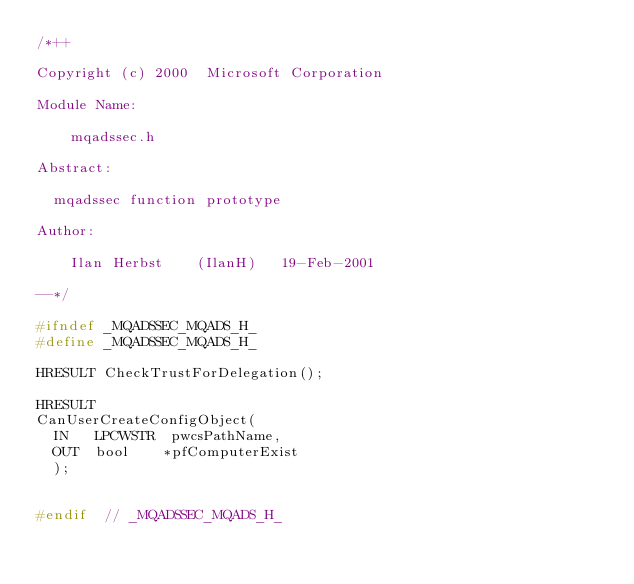<code> <loc_0><loc_0><loc_500><loc_500><_C_>/*++

Copyright (c) 2000  Microsoft Corporation

Module Name:

    mqadssec.h

Abstract:

	mqadssec function prototype

Author:

    Ilan Herbst    (IlanH)   19-Feb-2001 

--*/

#ifndef _MQADSSEC_MQADS_H_
#define _MQADSSEC_MQADS_H_

HRESULT CheckTrustForDelegation();

HRESULT 
CanUserCreateConfigObject(
	IN   LPCWSTR  pwcsPathName,
	OUT  bool    *pfComputerExist 
	);


#endif 	// _MQADSSEC_MQADS_H_
</code> 